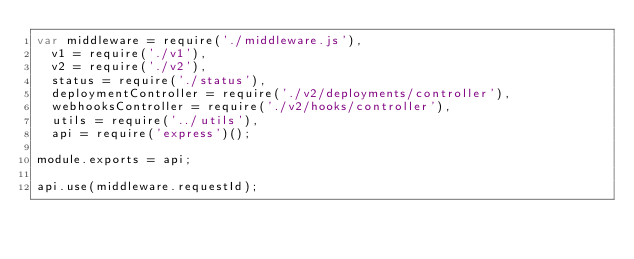<code> <loc_0><loc_0><loc_500><loc_500><_JavaScript_>var middleware = require('./middleware.js'),
  v1 = require('./v1'),
  v2 = require('./v2'),
  status = require('./status'),
  deploymentController = require('./v2/deployments/controller'),
  webhooksController = require('./v2/hooks/controller'),
  utils = require('../utils'),
  api = require('express')();

module.exports = api;

api.use(middleware.requestId);</code> 